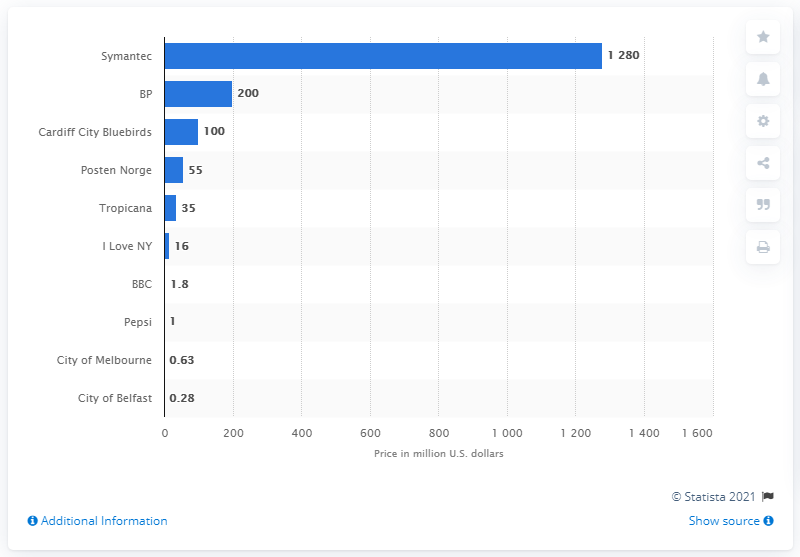List a handful of essential elements in this visual. The cost of Symantec's logo is unknown. The BBC paid 1.8 million dollars for its new logo. 